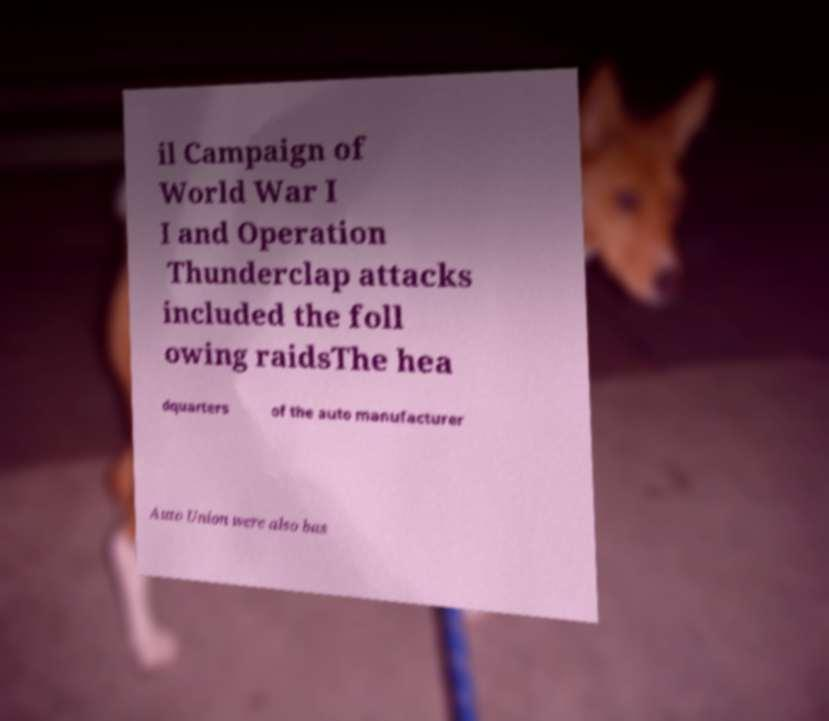Please read and relay the text visible in this image. What does it say? il Campaign of World War I I and Operation Thunderclap attacks included the foll owing raidsThe hea dquarters of the auto manufacturer Auto Union were also bas 